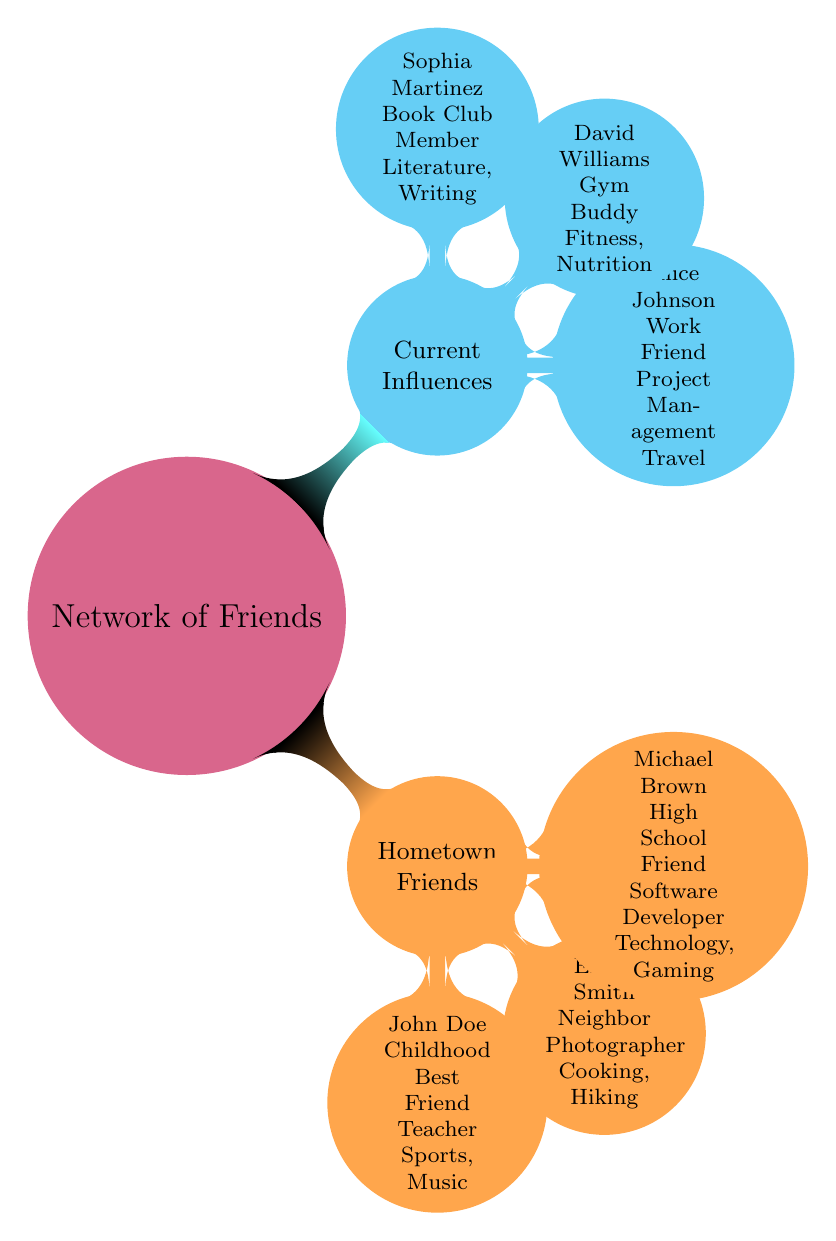What is the profession of John Doe? The node for John Doe states that his current occupation is "Teacher."
Answer: Teacher How many Hometown Friends are listed? The Hometown Friends section contains three nodes: John Doe, Emily Smith, and Michael Brown. Therefore, the total is three.
Answer: 3 What is the relation of Alice Johnson to the user? The diagram specifies that Alice Johnson is classified as a "Work Friend," which defines her relationship to the user.
Answer: Work Friend Which friend's key interests include Literature? The diagram indicates that Sophia Martinez has key interests in "Literature" as stated under her node.
Answer: Sophia Martinez What are the key interests of Michael Brown? The node for Michael Brown lists his key interests as "Technology" and "Gaming."
Answer: Technology, Gaming Which friend is associated with fitness? The diagram identifies David Williams as a "Gym Buddy," suggesting his association with fitness.
Answer: David Williams What is the connection between Emily Smith and John Doe? The diagram states that Emily Smith is a "Neighbor" of the user, while John Doe is a "Childhood Best Friend," indicating a close relationship but no direct familial connection.
Answer: No direct connection Which category does David Williams belong to? The diagram places David Williams under "Current Influences" as a "Gym Buddy," indicating his role in the user's life.
Answer: Current Influences Which two friends share an interest in cooking? The diagram shows that only Emily Smith has key interests in "Cooking"; no other friend shares this specific interest.
Answer: Emily Smith 